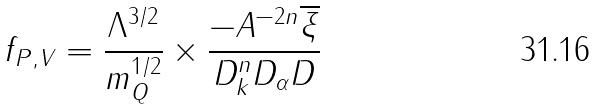Convert formula to latex. <formula><loc_0><loc_0><loc_500><loc_500>f _ { P , V } = \frac { \Lambda ^ { 3 / 2 } } { m _ { Q } ^ { 1 / 2 } } \times \frac { - A ^ { - 2 n } \overline { \xi } } { D _ { k } ^ { n } D _ { \alpha } D }</formula> 